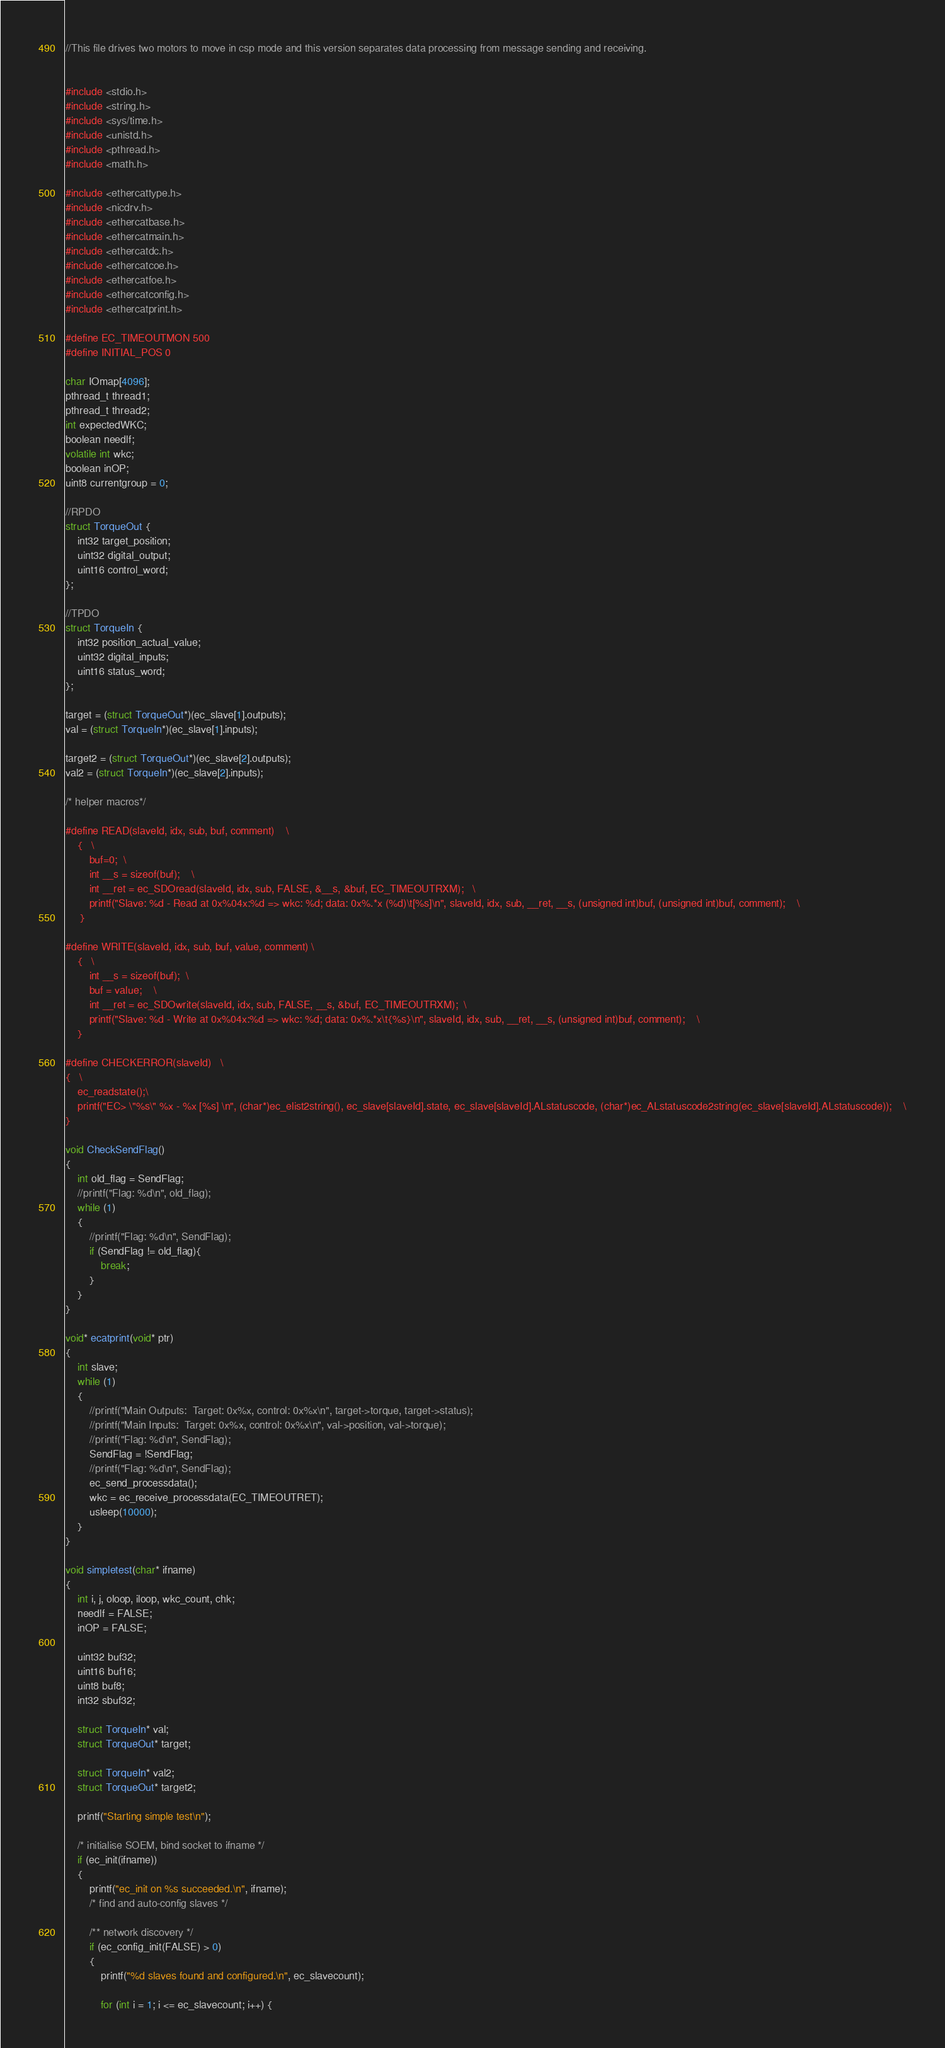<code> <loc_0><loc_0><loc_500><loc_500><_C_>//This file drives two motors to move in csp mode and this version separates data processing from message sending and receiving. 


#include <stdio.h>
#include <string.h>
#include <sys/time.h>
#include <unistd.h>
#include <pthread.h>
#include <math.h>

#include <ethercattype.h>
#include <nicdrv.h>
#include <ethercatbase.h>
#include <ethercatmain.h>
#include <ethercatdc.h>
#include <ethercatcoe.h>
#include <ethercatfoe.h>
#include <ethercatconfig.h>
#include <ethercatprint.h>

#define EC_TIMEOUTMON 500
#define INITIAL_POS 0

char IOmap[4096];
pthread_t thread1;
pthread_t thread2;
int expectedWKC;
boolean needlf;
volatile int wkc;
boolean inOP;
uint8 currentgroup = 0;

//RPDO
struct TorqueOut {
    int32 target_position;
    uint32 digital_output;
    uint16 control_word;
};

//TPDO
struct TorqueIn {
    int32 position_actual_value;
    uint32 digital_inputs;
    uint16 status_word;
};

target = (struct TorqueOut*)(ec_slave[1].outputs);
val = (struct TorqueIn*)(ec_slave[1].inputs);

target2 = (struct TorqueOut*)(ec_slave[2].outputs);
val2 = (struct TorqueIn*)(ec_slave[2].inputs);

/* helper macros*/

#define READ(slaveId, idx, sub, buf, comment)    \
    {   \
        buf=0;  \
        int __s = sizeof(buf);    \
        int __ret = ec_SDOread(slaveId, idx, sub, FALSE, &__s, &buf, EC_TIMEOUTRXM);   \
        printf("Slave: %d - Read at 0x%04x:%d => wkc: %d; data: 0x%.*x (%d)\t[%s]\n", slaveId, idx, sub, __ret, __s, (unsigned int)buf, (unsigned int)buf, comment);    \
     }

#define WRITE(slaveId, idx, sub, buf, value, comment) \
    {   \
        int __s = sizeof(buf);  \
        buf = value;    \
        int __ret = ec_SDOwrite(slaveId, idx, sub, FALSE, __s, &buf, EC_TIMEOUTRXM);  \
        printf("Slave: %d - Write at 0x%04x:%d => wkc: %d; data: 0x%.*x\t{%s}\n", slaveId, idx, sub, __ret, __s, (unsigned int)buf, comment);    \
    }

#define CHECKERROR(slaveId)   \
{   \
    ec_readstate();\
    printf("EC> \"%s\" %x - %x [%s] \n", (char*)ec_elist2string(), ec_slave[slaveId].state, ec_slave[slaveId].ALstatuscode, (char*)ec_ALstatuscode2string(ec_slave[slaveId].ALstatuscode));    \
}

void CheckSendFlag()
{
    int old_flag = SendFlag;
    //printf("Flag: %d\n", old_flag);
    while (1)
    {   
        //printf("Flag: %d\n", SendFlag);
        if (SendFlag != old_flag){
            break;
        }
    }
}

void* ecatprint(void* ptr)
{
    int slave;
    while (1)
    {
        //printf("Main Outputs:  Target: 0x%x, control: 0x%x\n", target->torque, target->status);
        //printf("Main Inputs:  Target: 0x%x, control: 0x%x\n", val->position, val->torque);
        //printf("Flag: %d\n", SendFlag);
        SendFlag = !SendFlag;
        //printf("Flag: %d\n", SendFlag);
        ec_send_processdata();
        wkc = ec_receive_processdata(EC_TIMEOUTRET);
        usleep(10000);
    }
}

void simpletest(char* ifname)
{
    int i, j, oloop, iloop, wkc_count, chk;
    needlf = FALSE;
    inOP = FALSE;

    uint32 buf32;
    uint16 buf16;
    uint8 buf8;
    int32 sbuf32;

    struct TorqueIn* val;
    struct TorqueOut* target;

    struct TorqueIn* val2;
    struct TorqueOut* target2;

    printf("Starting simple test\n");

    /* initialise SOEM, bind socket to ifname */
    if (ec_init(ifname))
    {
        printf("ec_init on %s succeeded.\n", ifname);
        /* find and auto-config slaves */

        /** network discovery */
        if (ec_config_init(FALSE) > 0)
        {
            printf("%d slaves found and configured.\n", ec_slavecount);

            for (int i = 1; i <= ec_slavecount; i++) {</code> 